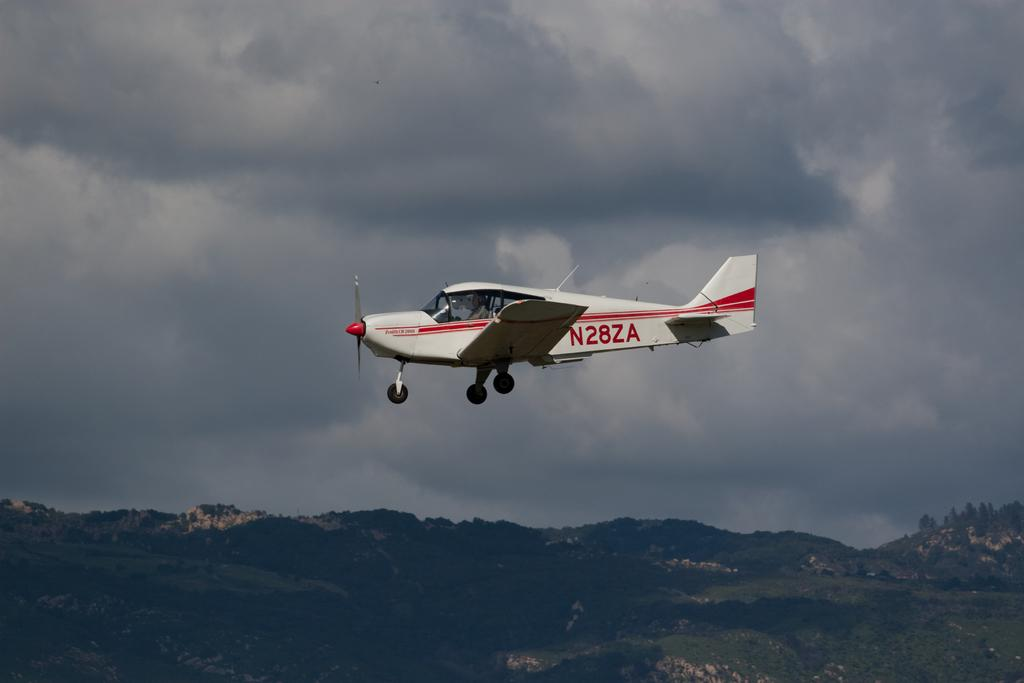What is the main subject of the image? The main subject of the image is an aircraft flying. What can be seen in the background of the image? Mountains, trees, and the sky are visible in the background of the image. What is the condition of the sky in the image? The sky is visible in the image, and clouds are present. What type of cover is being used to protect the trees in the image? There is no cover present in the image; the trees are visible in their natural state. How many streams can be seen flowing through the mountains in the image? There are no streams visible in the image; the image only shows mountains, trees, and the sky. 